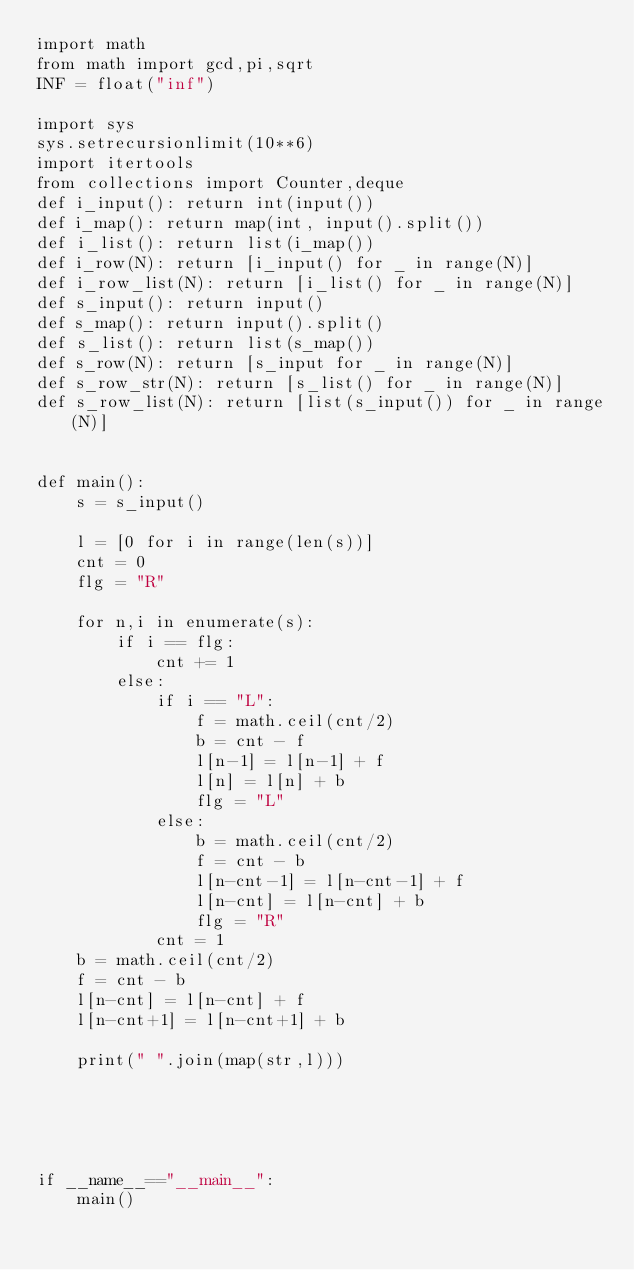Convert code to text. <code><loc_0><loc_0><loc_500><loc_500><_Python_>import math
from math import gcd,pi,sqrt
INF = float("inf")

import sys
sys.setrecursionlimit(10**6)
import itertools
from collections import Counter,deque
def i_input(): return int(input())
def i_map(): return map(int, input().split())
def i_list(): return list(i_map())
def i_row(N): return [i_input() for _ in range(N)]
def i_row_list(N): return [i_list() for _ in range(N)]
def s_input(): return input()
def s_map(): return input().split()
def s_list(): return list(s_map())
def s_row(N): return [s_input for _ in range(N)]
def s_row_str(N): return [s_list() for _ in range(N)]
def s_row_list(N): return [list(s_input()) for _ in range(N)]


def main():
    s = s_input()

    l = [0 for i in range(len(s))]
    cnt = 0
    flg = "R"

    for n,i in enumerate(s):
        if i == flg:
            cnt += 1
        else:
            if i == "L":
                f = math.ceil(cnt/2)
                b = cnt - f
                l[n-1] = l[n-1] + f
                l[n] = l[n] + b
                flg = "L"
            else:
                b = math.ceil(cnt/2)
                f = cnt - b
                l[n-cnt-1] = l[n-cnt-1] + f
                l[n-cnt] = l[n-cnt] + b
                flg = "R"
            cnt = 1
    b = math.ceil(cnt/2)
    f = cnt - b
    l[n-cnt] = l[n-cnt] + f
    l[n-cnt+1] = l[n-cnt+1] + b

    print(" ".join(map(str,l)))





if __name__=="__main__":
    main()
</code> 